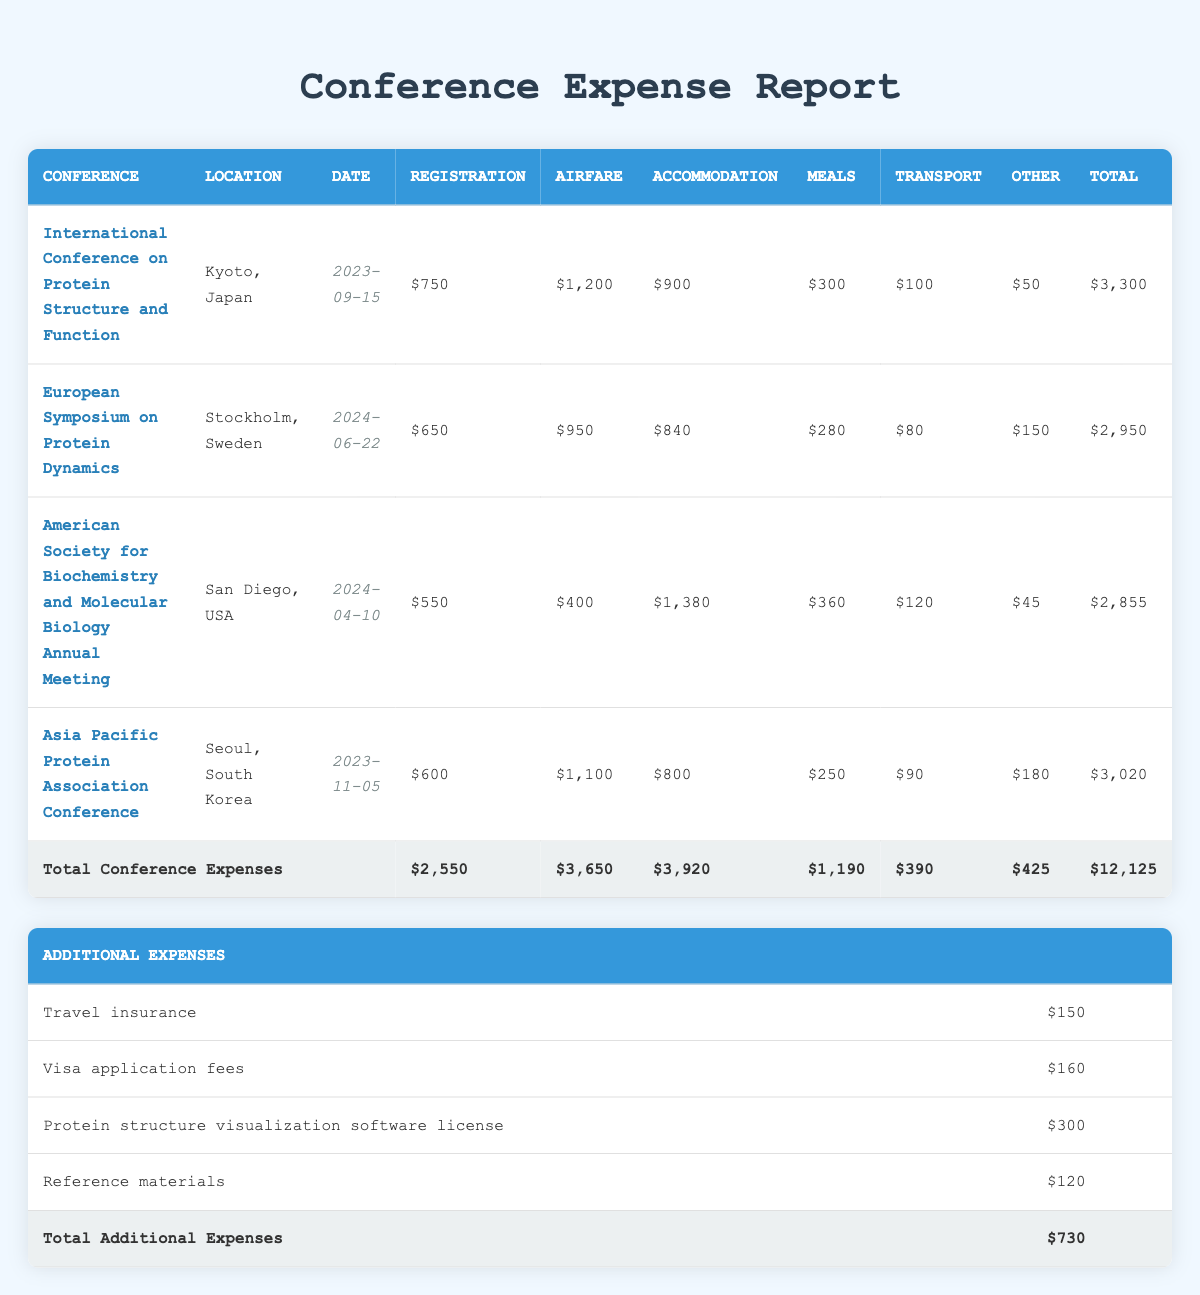What is the total registration fee for all conferences? To find the total registration fee, we add the registration fees from all listed conferences: 750 + 650 + 550 + 600 = 2,550.
Answer: 2,550 Which conference has the highest airfare expense? Reviewing the airfare expenses, we see that the International Conference on Protein Structure and Function has 1,200, whereas the other airfares are lower: 950, 400, and 1,100. Hence, the highest is 1,200.
Answer: International Conference on Protein Structure and Function What is the average accommodation cost per night across all conferences? We first calculate the total accommodation costs: (900 + 840 + 1,380 + 800) = 3,920. Next, we find the total number of nights across all conferences: (5 + 4 + 6 + 4) = 19. Finally, we compute the average: 3,920 / 19 = approximately 206.32.
Answer: 206.32 Is there a workshop fee for the European Symposium on Protein Dynamics? Checking the entry for this conference, a workshop fee of 150 is listed, indicating that yes, there is a workshop fee.
Answer: Yes What is the combined total cost of the additional expenses? Adding the costs of the additional expenses gives us: 150 + 160 + 300 + 120 = 730. Thus, the combined total is 730.
Answer: 730 Which conference expense is the lowest total cost? We need to sum the total costs for each conference: 3,300, 2,950, 2,855, and 3,020. The lowest total is 2,855 for the American Society for Biochemistry and Molecular Biology Annual Meeting.
Answer: American Society for Biochemistry and Molecular Biology Annual Meeting What is the total cost if we exclude the local transportation from all conferences? We calculate the total expenses for each conference, excluding local transportation: (3,300 - 100) + (2,950 - 80) + (2,855 - 120) + (3,020 - 90) = 3,200 + 2,870 + 2,735 + 2,930 = 11,735. The total without local transportation is 11,735.
Answer: 11,735 Does the Asia Pacific Protein Association Conference have a higher total expense than the American Society for Biochemistry and Molecular Biology Annual Meeting? Comparing the totals, the Asia Pacific Protein Association Conference has 3,020, while the American Society for Biochemistry and Molecular Biology Annual Meeting has 2,855. Since 3,020 is greater than 2,855, we conclude yes.
Answer: Yes 